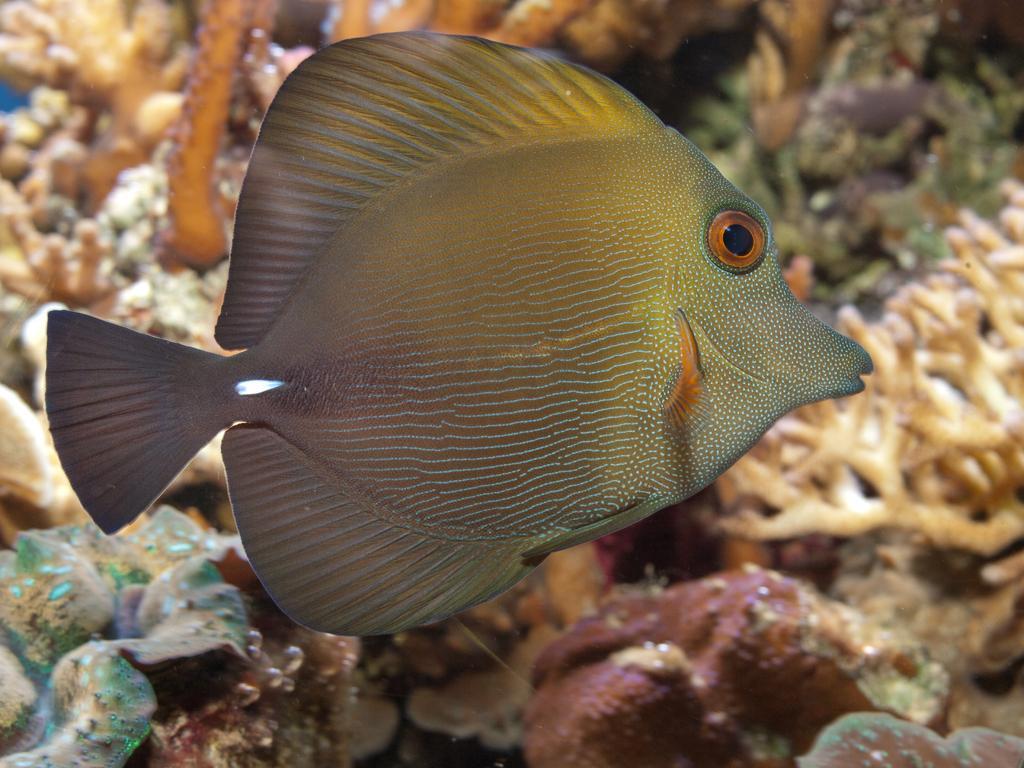Can you describe this image briefly? In this picture I can see a fish and corals in the water. 